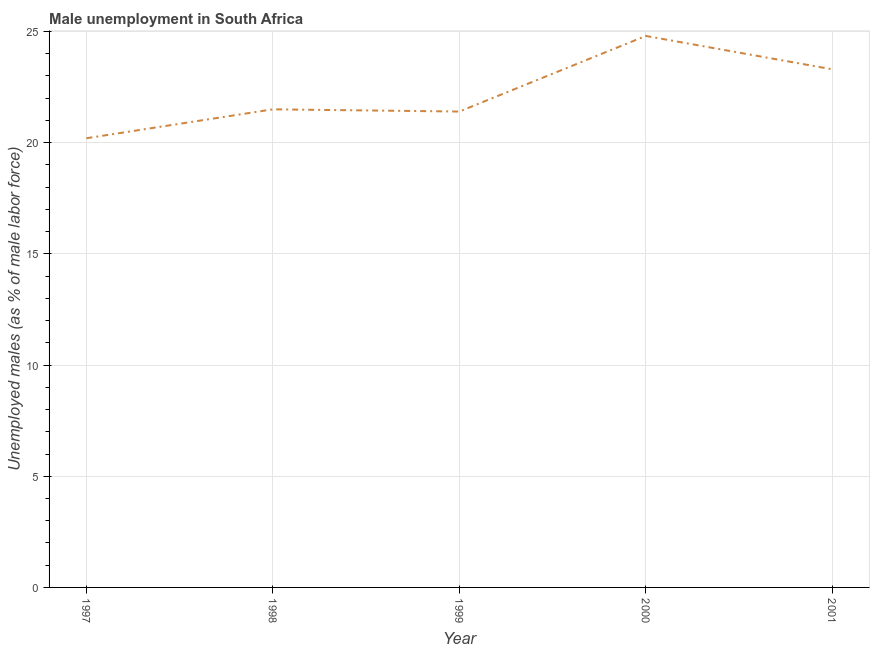What is the unemployed males population in 1999?
Provide a succinct answer. 21.4. Across all years, what is the maximum unemployed males population?
Ensure brevity in your answer.  24.8. Across all years, what is the minimum unemployed males population?
Provide a succinct answer. 20.2. In which year was the unemployed males population maximum?
Offer a very short reply. 2000. What is the sum of the unemployed males population?
Keep it short and to the point. 111.2. What is the difference between the unemployed males population in 1999 and 2001?
Your answer should be very brief. -1.9. What is the average unemployed males population per year?
Give a very brief answer. 22.24. What is the median unemployed males population?
Ensure brevity in your answer.  21.5. In how many years, is the unemployed males population greater than 5 %?
Offer a terse response. 5. Do a majority of the years between 1998 and 2001 (inclusive) have unemployed males population greater than 18 %?
Your answer should be compact. Yes. What is the ratio of the unemployed males population in 1999 to that in 2001?
Offer a very short reply. 0.92. Is the unemployed males population in 1999 less than that in 2001?
Make the answer very short. Yes. Is the difference between the unemployed males population in 1997 and 2001 greater than the difference between any two years?
Provide a short and direct response. No. Is the sum of the unemployed males population in 1997 and 2000 greater than the maximum unemployed males population across all years?
Make the answer very short. Yes. What is the difference between the highest and the lowest unemployed males population?
Give a very brief answer. 4.6. In how many years, is the unemployed males population greater than the average unemployed males population taken over all years?
Provide a short and direct response. 2. Does the unemployed males population monotonically increase over the years?
Your answer should be compact. No. Does the graph contain any zero values?
Your answer should be very brief. No. What is the title of the graph?
Offer a terse response. Male unemployment in South Africa. What is the label or title of the X-axis?
Your answer should be compact. Year. What is the label or title of the Y-axis?
Keep it short and to the point. Unemployed males (as % of male labor force). What is the Unemployed males (as % of male labor force) in 1997?
Keep it short and to the point. 20.2. What is the Unemployed males (as % of male labor force) of 1998?
Offer a very short reply. 21.5. What is the Unemployed males (as % of male labor force) in 1999?
Offer a terse response. 21.4. What is the Unemployed males (as % of male labor force) in 2000?
Give a very brief answer. 24.8. What is the Unemployed males (as % of male labor force) of 2001?
Ensure brevity in your answer.  23.3. What is the difference between the Unemployed males (as % of male labor force) in 1997 and 1998?
Keep it short and to the point. -1.3. What is the difference between the Unemployed males (as % of male labor force) in 1997 and 1999?
Give a very brief answer. -1.2. What is the difference between the Unemployed males (as % of male labor force) in 1997 and 2000?
Give a very brief answer. -4.6. What is the difference between the Unemployed males (as % of male labor force) in 1997 and 2001?
Provide a short and direct response. -3.1. What is the difference between the Unemployed males (as % of male labor force) in 1998 and 1999?
Your answer should be very brief. 0.1. What is the difference between the Unemployed males (as % of male labor force) in 1998 and 2000?
Your answer should be very brief. -3.3. What is the difference between the Unemployed males (as % of male labor force) in 1998 and 2001?
Ensure brevity in your answer.  -1.8. What is the difference between the Unemployed males (as % of male labor force) in 1999 and 2001?
Provide a short and direct response. -1.9. What is the ratio of the Unemployed males (as % of male labor force) in 1997 to that in 1999?
Give a very brief answer. 0.94. What is the ratio of the Unemployed males (as % of male labor force) in 1997 to that in 2000?
Your answer should be very brief. 0.81. What is the ratio of the Unemployed males (as % of male labor force) in 1997 to that in 2001?
Ensure brevity in your answer.  0.87. What is the ratio of the Unemployed males (as % of male labor force) in 1998 to that in 2000?
Give a very brief answer. 0.87. What is the ratio of the Unemployed males (as % of male labor force) in 1998 to that in 2001?
Offer a terse response. 0.92. What is the ratio of the Unemployed males (as % of male labor force) in 1999 to that in 2000?
Provide a succinct answer. 0.86. What is the ratio of the Unemployed males (as % of male labor force) in 1999 to that in 2001?
Offer a terse response. 0.92. What is the ratio of the Unemployed males (as % of male labor force) in 2000 to that in 2001?
Keep it short and to the point. 1.06. 